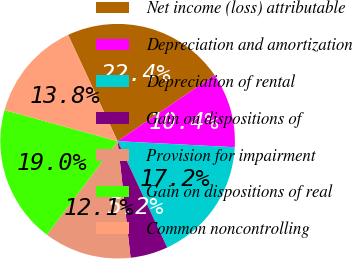<chart> <loc_0><loc_0><loc_500><loc_500><pie_chart><fcel>Net income (loss) attributable<fcel>Depreciation and amortization<fcel>Depreciation of rental<fcel>Gain on dispositions of<fcel>Provision for impairment<fcel>Gain on dispositions of real<fcel>Common noncontrolling<nl><fcel>22.41%<fcel>10.35%<fcel>17.24%<fcel>5.18%<fcel>12.07%<fcel>18.96%<fcel>13.79%<nl></chart> 